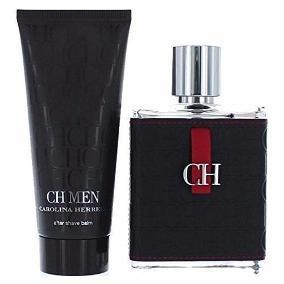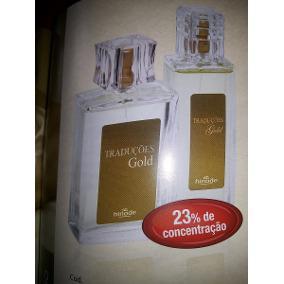The first image is the image on the left, the second image is the image on the right. Assess this claim about the two images: "There is a total of 1 black box.". Correct or not? Answer yes or no. No. 